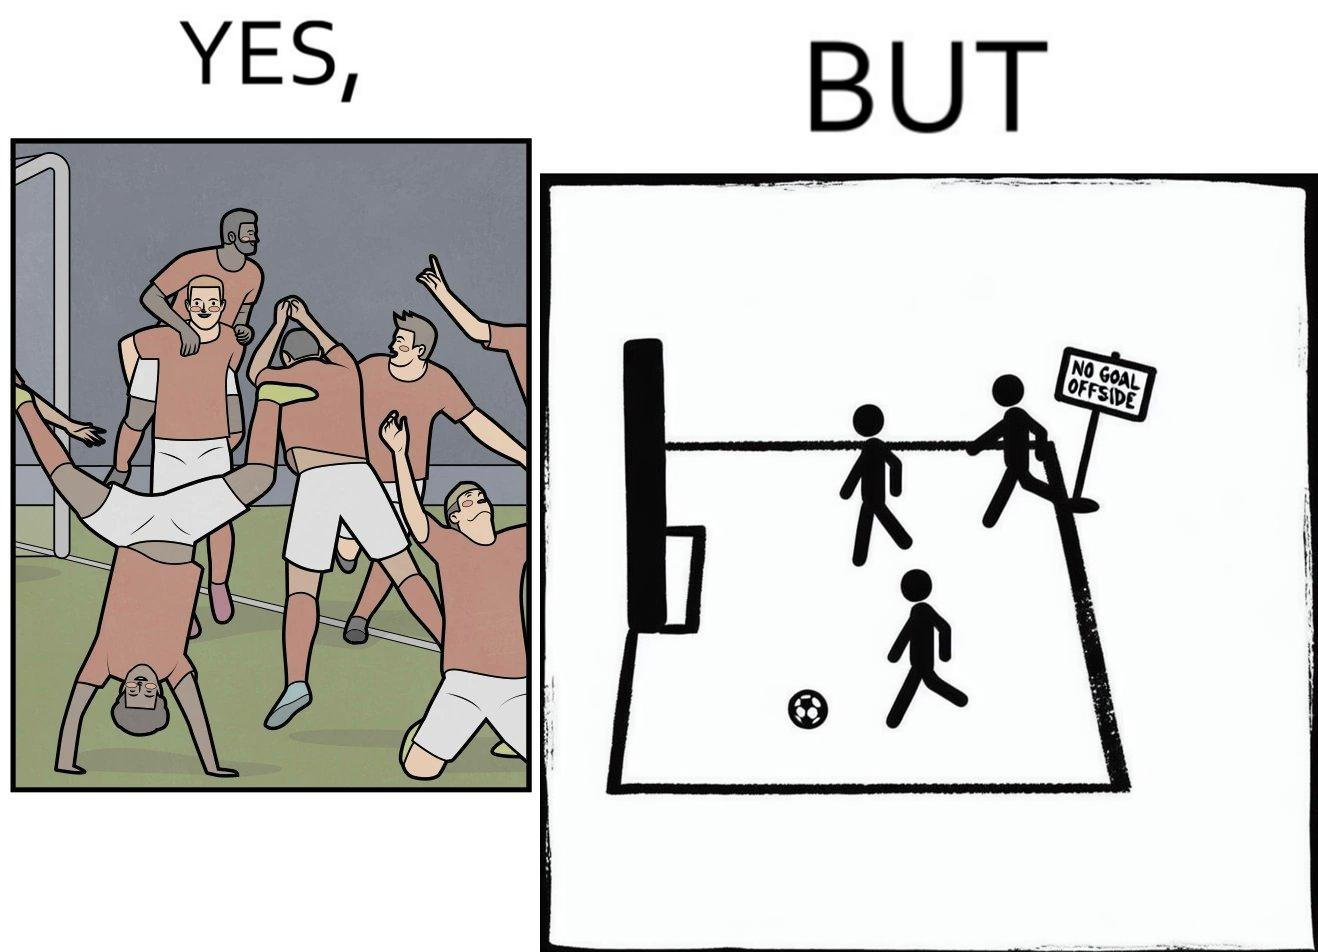What do you see in each half of this image? In the left part of the image: football players celebrating, probably due a goal their team has scored. In the right part of the image: A sign of "No goal - Offside". 